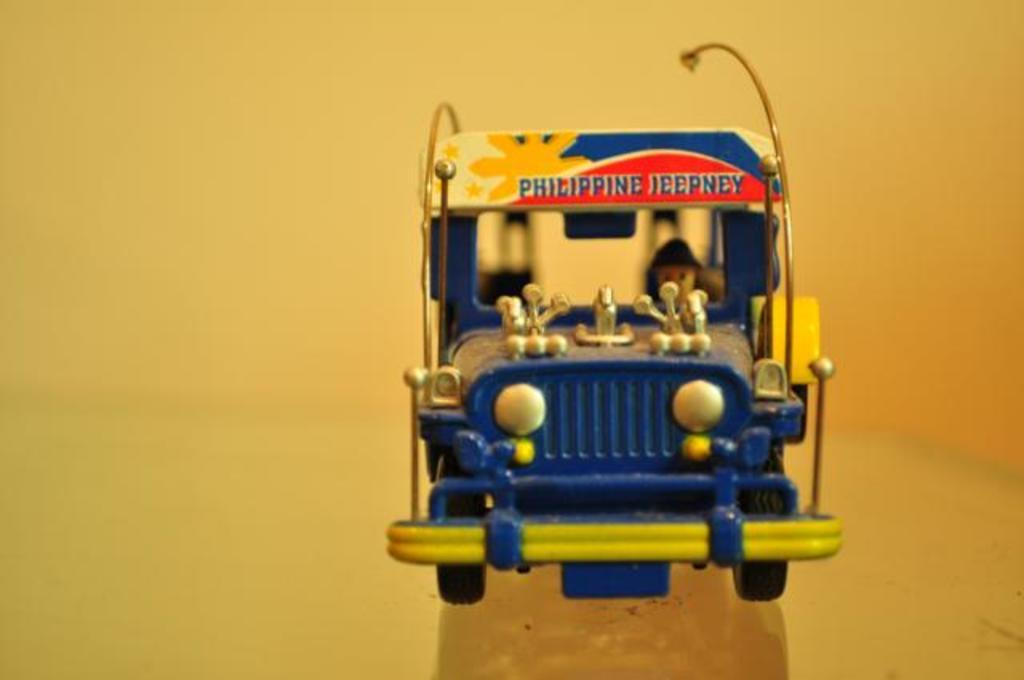What type of toy is present in the image? There is a toy of a vehicle in the picture. What color is the toy? The toy is blue in color. Are there any markings or text on the toy? Yes, there is writing on the toy. What color is the background of the image? The background of the image is yellow in color. How many beds are visible in the image? There are no beds present in the image. What type of drink is being served in the image? There is no drink present in the image. 